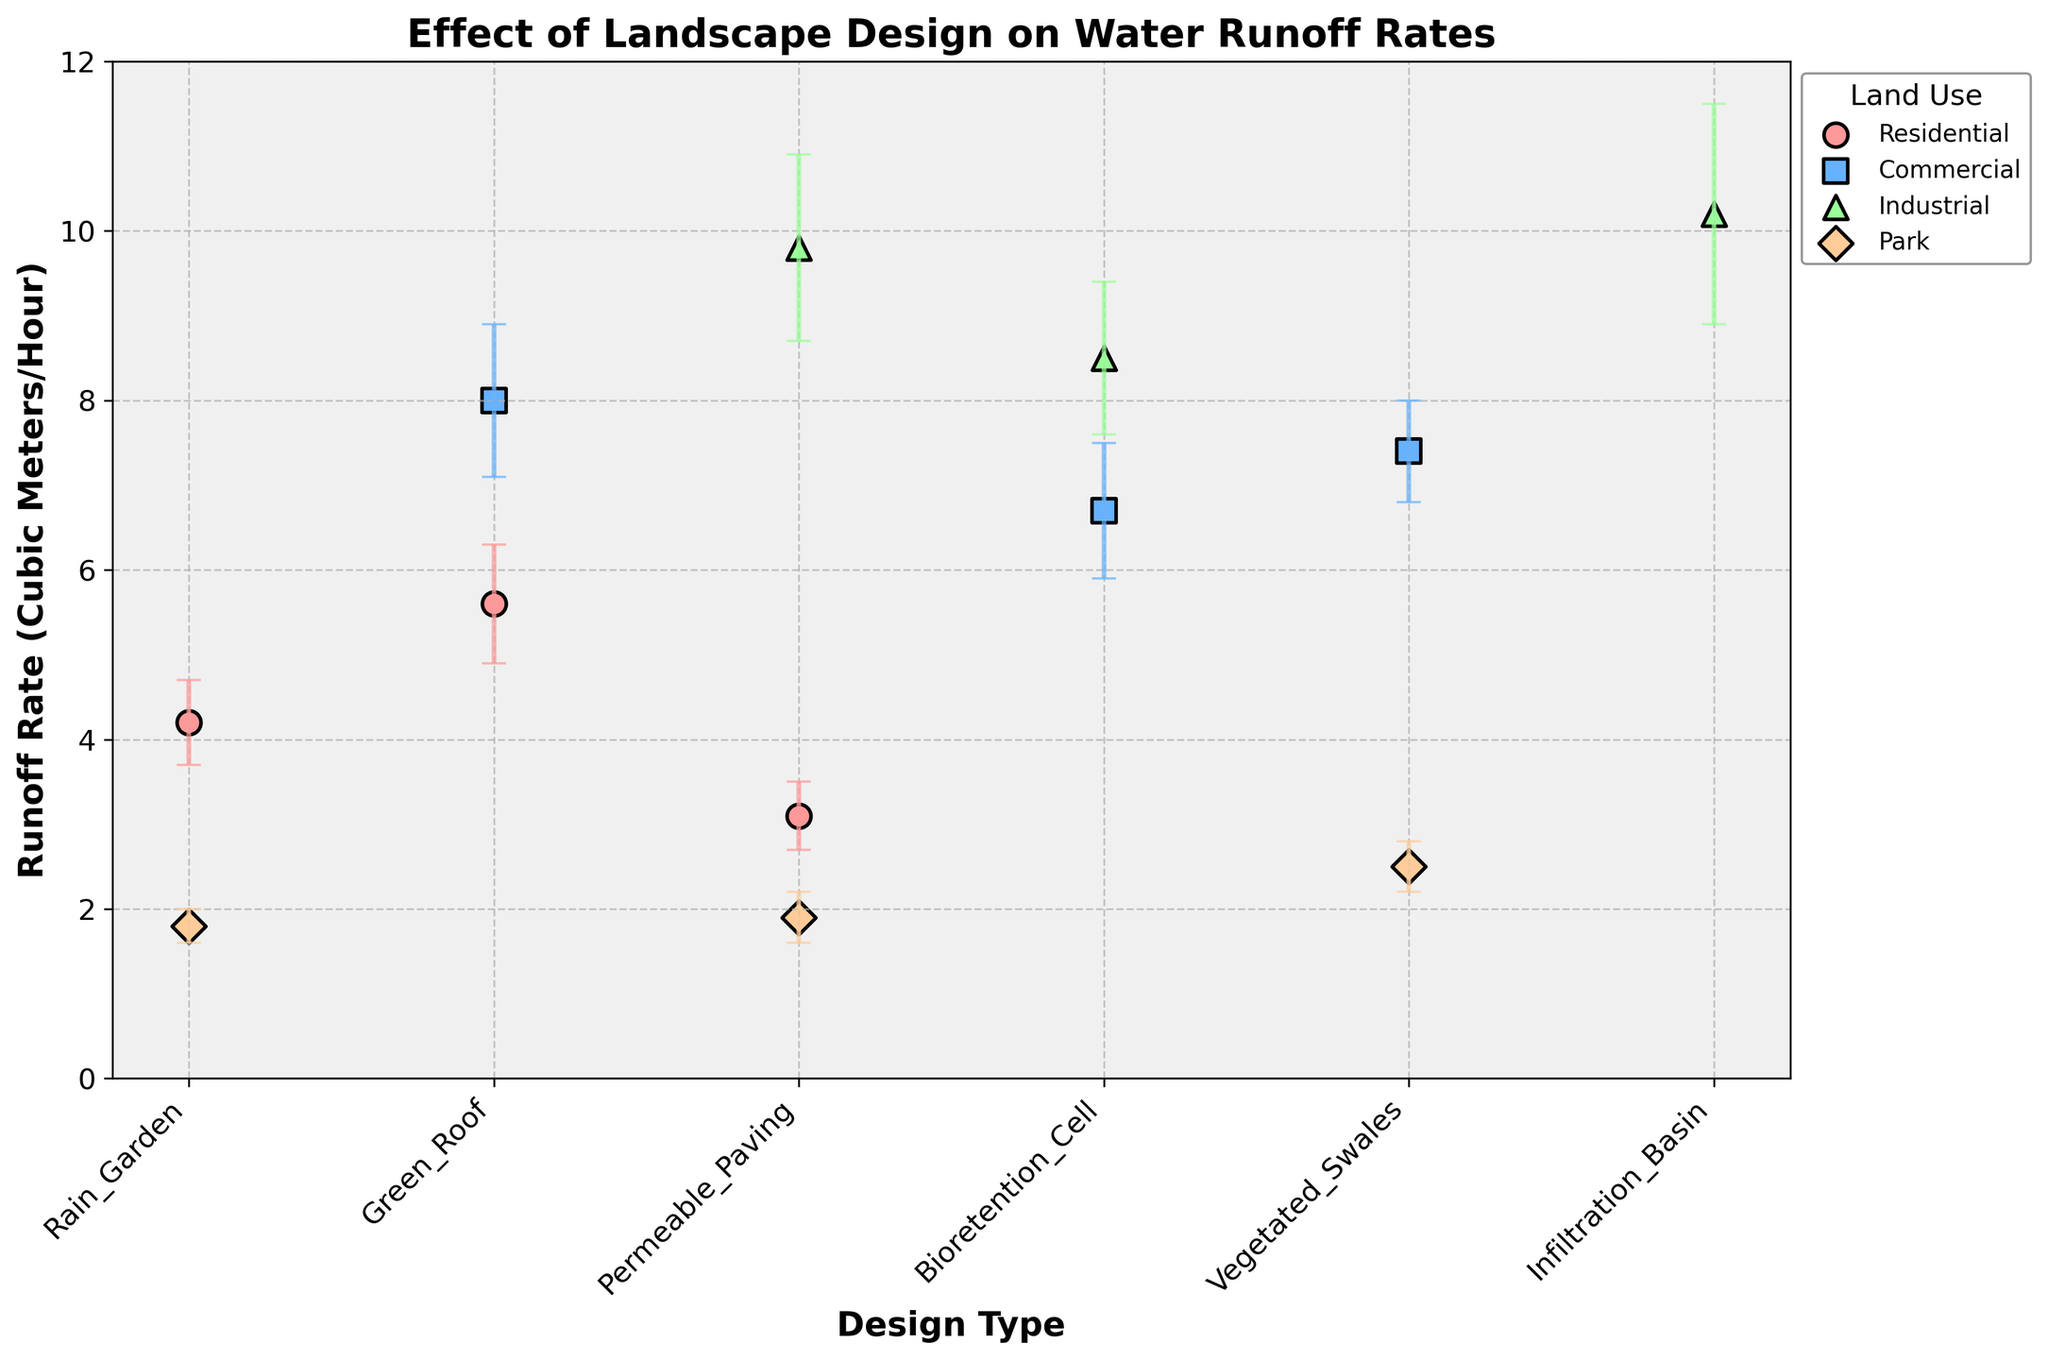What's the title of the figure? The title is located at the top of the figure. It provides a brief description of what the figure is about.
Answer: Effect of Landscape Design on Water Runoff Rates What is the range of runoff rates represented in the figure? The y-axis depicts the runoff rate (in cubic meters per hour) and the range starts from 0 and goes up to 12.
Answer: 0 to 12 cubic meters per hour Which design type has the highest and lowest runoff rates in residential land use? By looking at the residential data points along with their runoff rate values, we see that Green Roof has the highest runoff rate value (5.6) while Permeable Paving has the lowest (3.1).
Answer: Highest: Green Roof, Lowest: Permeable Paving Comparing the error margins, which industrial design type shows the greatest uncertainty in the runoff rate? The error margin for each design type can be inferred from the length of the error bars. Among the industrial designs, Infiltration Basin has the largest error margin (1.3), indicating the greatest uncertainty.
Answer: Infiltration Basin For parks, which design type has the minimum runoff rate and how much lower is it compared to the maximum runoff rate in parks? We identify the design type with the smallest runoff rate (Rain Garden - 1.8) and then find the one with the largest runoff rate (Vegetated Swales - 2.5). The difference is calculated as 2.5 - 1.8.
Answer: Rain Garden; 0.7 cubic meters per hour lower What is the average runoff rate for commercial land use across all design types shown? We take the runoff rate values for all commercial design types (Bioretention Cell: 6.7, Green Roof: 8.0, Vegetated Swales: 7.4), sum them up and divide by the number of data points. ((6.7 + 8.0 + 7.4) / 3) = 22.1 / 3.
Answer: 7.37 cubic meters per hour Which design type tends to have the most consistent (smallest error margin) runoff rates across different land uses? We observe the error bars across all land-use categories and identify the design type that frequently shows smaller error bars. Permeable Paving tends to show consistently smaller error margins, especially in Residential and Park land uses.
Answer: Permeable Paving Does industrial land use generally exhibit higher runoff rates compared to other land uses? We compare the general range of runoff rates for industrial land use with other land-use categories. Industrial design types generally have higher absolute runoff rates (greater than 8 cubic meters per hour) compared to residential, commercial, and parks.
Answer: Yes 